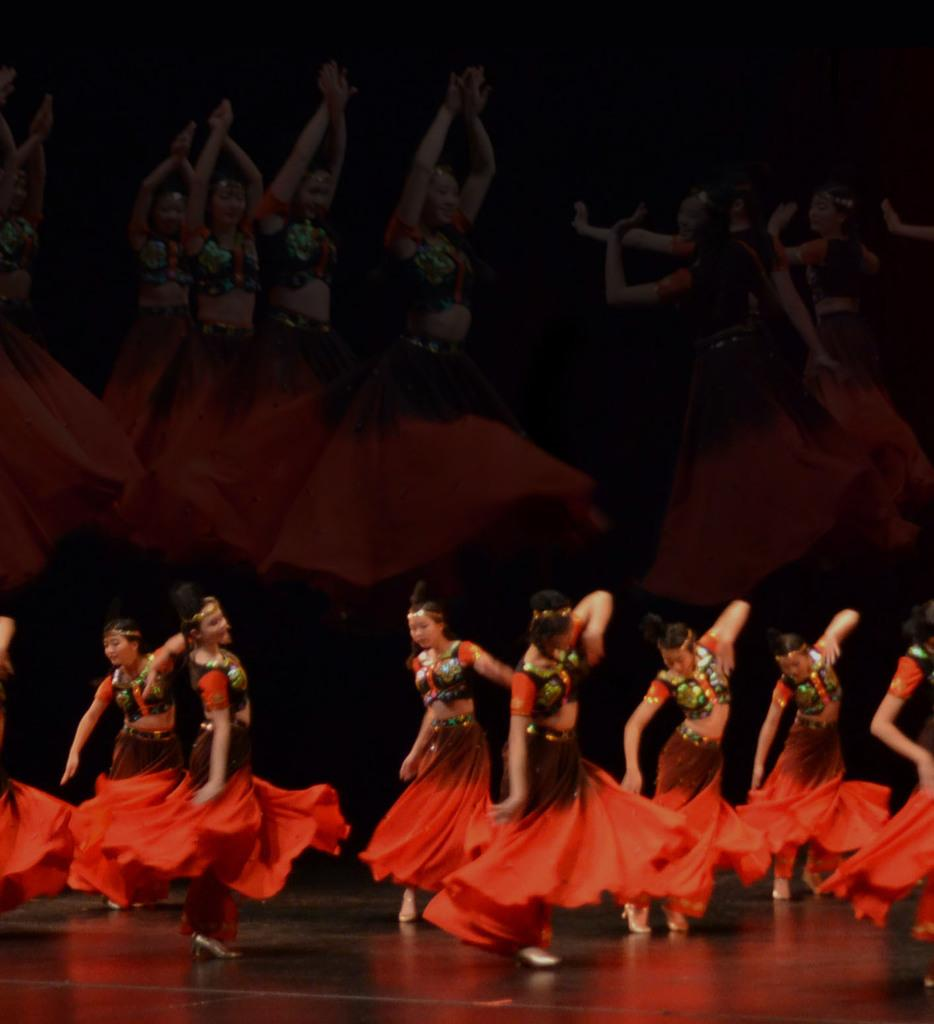What is the main subject of the image? The main subject of the image is a group of girls. What are the girls wearing in the image? The girls are wearing red dresses in the image. Where are the girls in the image? The girls are dancing on a stage in the image. What is behind the girls on the stage? There is a screen behind the girls in the image. What is the screen doing in the image? The screen reflects the girls' images in the image. What type of sleet can be seen falling on the girls during their performance? There is no sleet present in the image; it is an indoor performance on a stage. How many rings are visible on the girls' fingers in the image? There is no mention of rings on the girls' fingers in the image. 